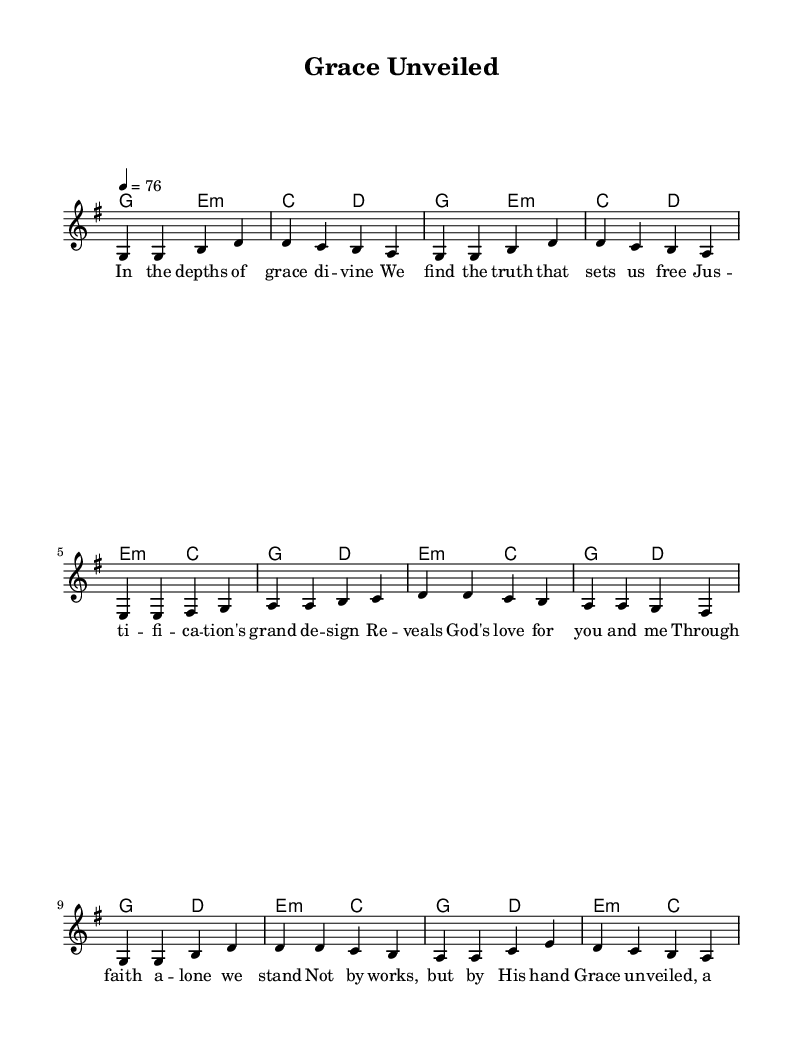What is the key signature of this music? The key signature is G major, which has one sharp (F#). This can be identified from the global settings stated in the code.
Answer: G major What is the time signature of this music? The time signature is four-four time, indicated in the global settings section of the code. This means there are four beats per measure.
Answer: 4/4 What is the tempo marking of this piece? The tempo marking is quarter note equals seventy-six, which sets the speed of the music. This is specified in the global section of the code.
Answer: 76 How many verses are there in "Grace Unveiled"? There is one verse present in the provided sheet music, which is reflected in the lyrics section where only one verse is written.
Answer: One What is the primary theme conveyed in the lyrics? The primary theme of the lyrics emphasizes grace and justification through faith, highlighting God's love and righteousness, which is central to contemporary Christian worship. Analyzing the text reveals key theological concepts woven throughout.
Answer: Grace and justification In the pre-chorus, how is faith described? Faith is described as standing through faith alone, emphasizing reliance on God rather than personal effort. This interpretation can be deduced from the lyrics provided in the pre-chorus section.
Answer: Through faith alone What are the main chords used in the chorus? The main chords in the chorus are G major, D major, E minor, and C major, as outlined in the harmonies section of the code. This can be inferred from the chord sequences aligning with the melody.
Answer: G, D, E minor, C 